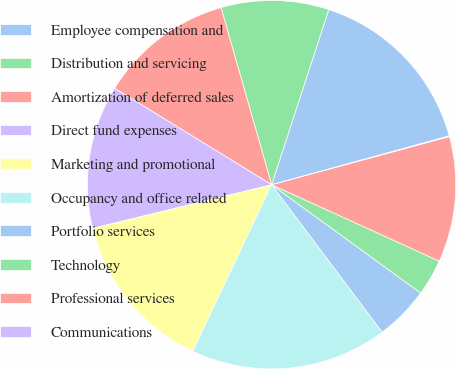Convert chart to OTSL. <chart><loc_0><loc_0><loc_500><loc_500><pie_chart><fcel>Employee compensation and<fcel>Distribution and servicing<fcel>Amortization of deferred sales<fcel>Direct fund expenses<fcel>Marketing and promotional<fcel>Occupancy and office related<fcel>Portfolio services<fcel>Technology<fcel>Professional services<fcel>Communications<nl><fcel>15.71%<fcel>9.45%<fcel>11.8%<fcel>12.58%<fcel>14.15%<fcel>17.28%<fcel>4.76%<fcel>3.19%<fcel>11.02%<fcel>0.06%<nl></chart> 